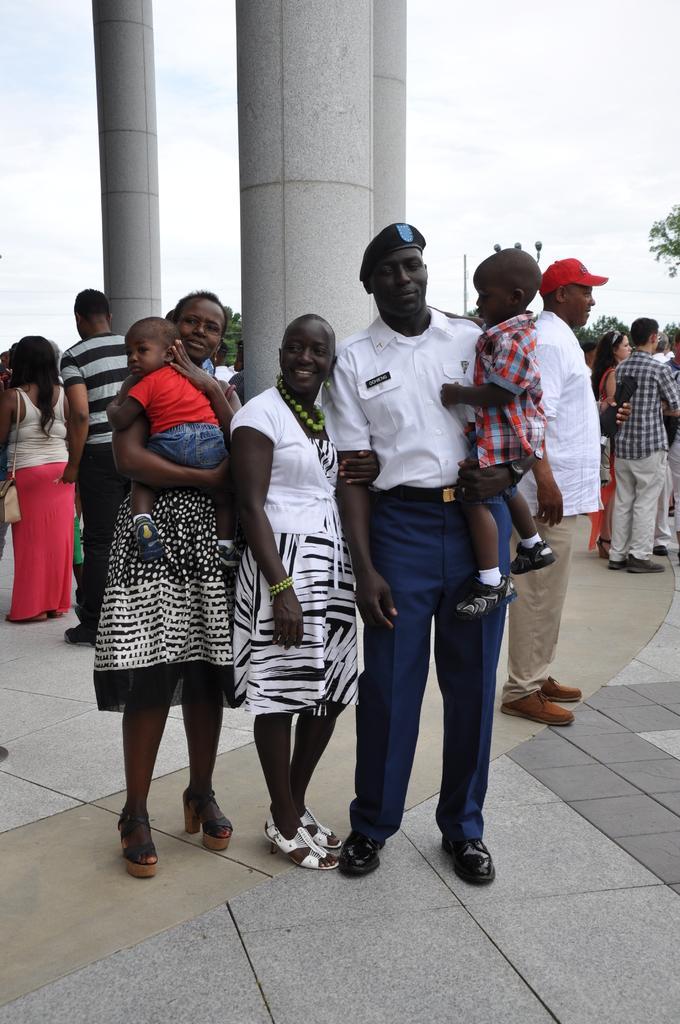Describe this image in one or two sentences. In this picture I can see there are few people standing here and among them there are two women wearing dress and the man is wearing a white shirt and a blue pant with a cap and in the backdrop I can see there are few people standing and there are trees and the sky is clear. 